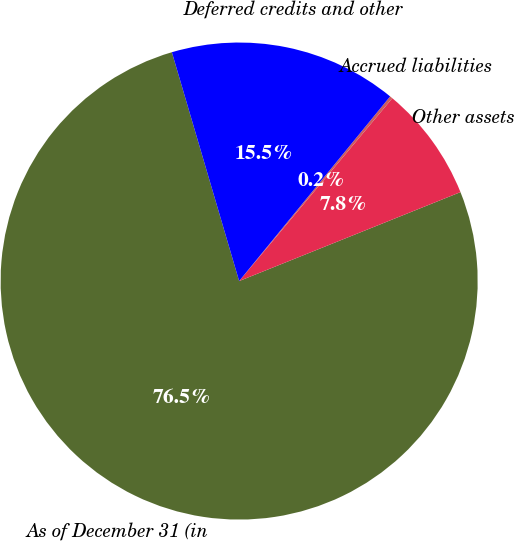<chart> <loc_0><loc_0><loc_500><loc_500><pie_chart><fcel>As of December 31 (in<fcel>Other assets<fcel>Accrued liabilities<fcel>Deferred credits and other<nl><fcel>76.53%<fcel>7.82%<fcel>0.19%<fcel>15.46%<nl></chart> 